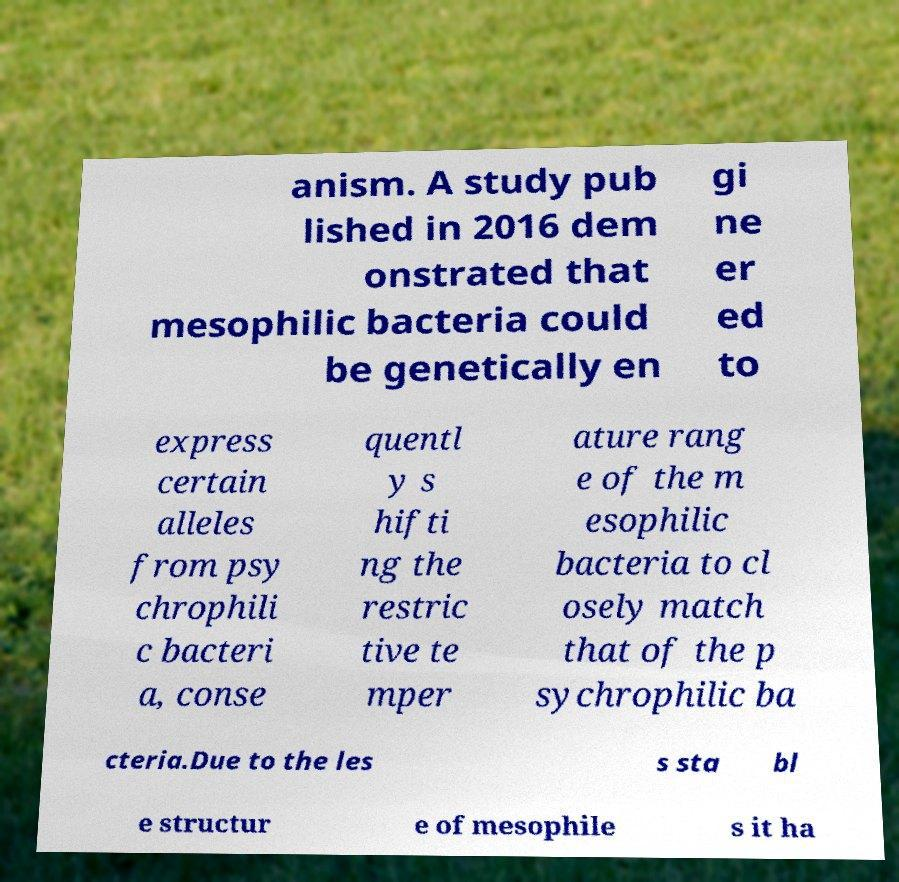There's text embedded in this image that I need extracted. Can you transcribe it verbatim? anism. A study pub lished in 2016 dem onstrated that mesophilic bacteria could be genetically en gi ne er ed to express certain alleles from psy chrophili c bacteri a, conse quentl y s hifti ng the restric tive te mper ature rang e of the m esophilic bacteria to cl osely match that of the p sychrophilic ba cteria.Due to the les s sta bl e structur e of mesophile s it ha 